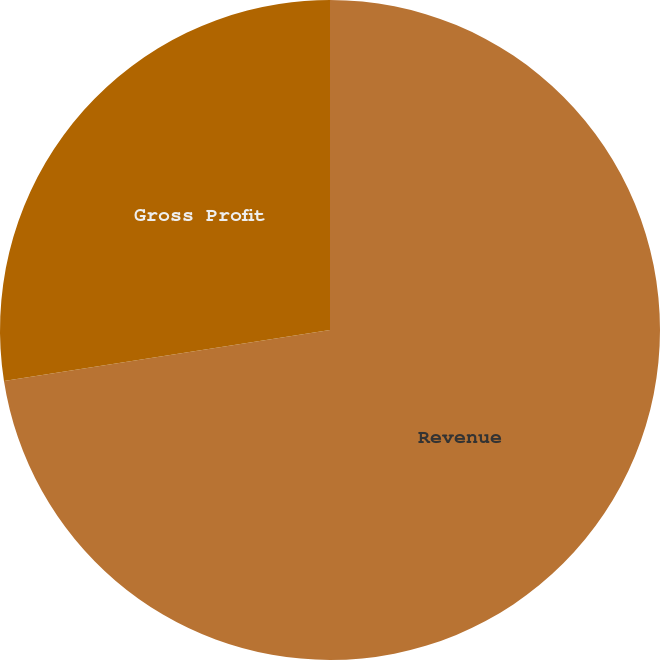<chart> <loc_0><loc_0><loc_500><loc_500><pie_chart><fcel>Revenue<fcel>Gross Profit<nl><fcel>72.53%<fcel>27.47%<nl></chart> 